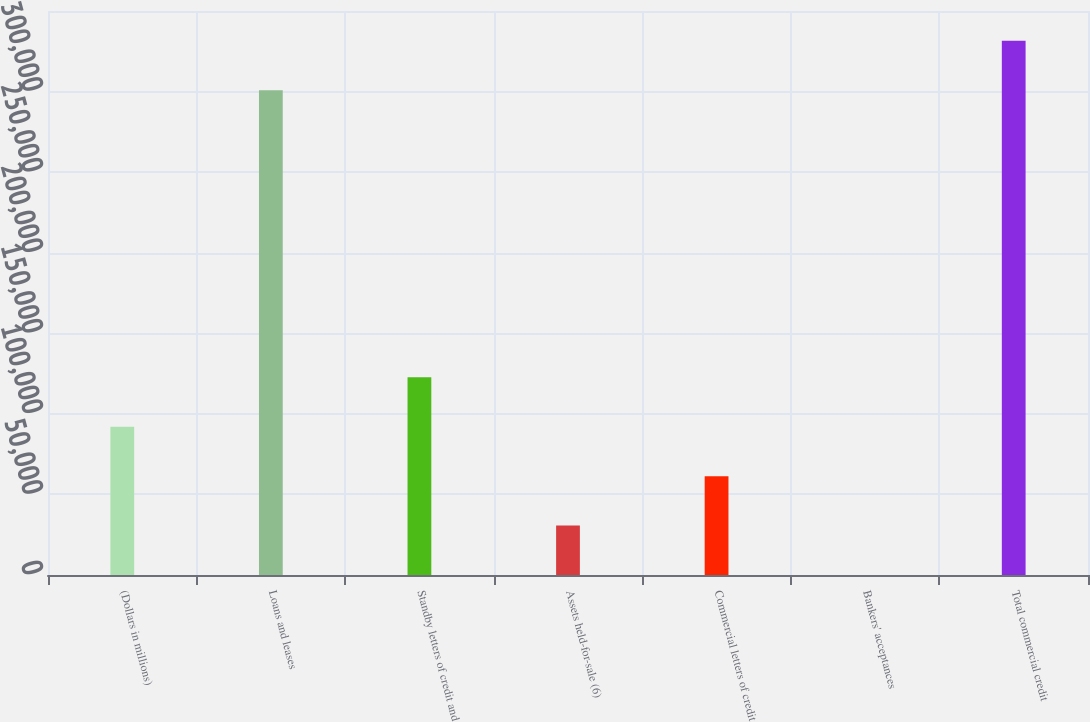Convert chart to OTSL. <chart><loc_0><loc_0><loc_500><loc_500><bar_chart><fcel>(Dollars in millions)<fcel>Loans and leases<fcel>Standby letters of credit and<fcel>Assets held-for-sale (6)<fcel>Commercial letters of credit<fcel>Bankers' acceptances<fcel>Total commercial credit<nl><fcel>91984<fcel>300856<fcel>122641<fcel>30670<fcel>61327<fcel>13<fcel>331513<nl></chart> 